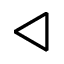Convert formula to latex. <formula><loc_0><loc_0><loc_500><loc_500>\triangleleft</formula> 